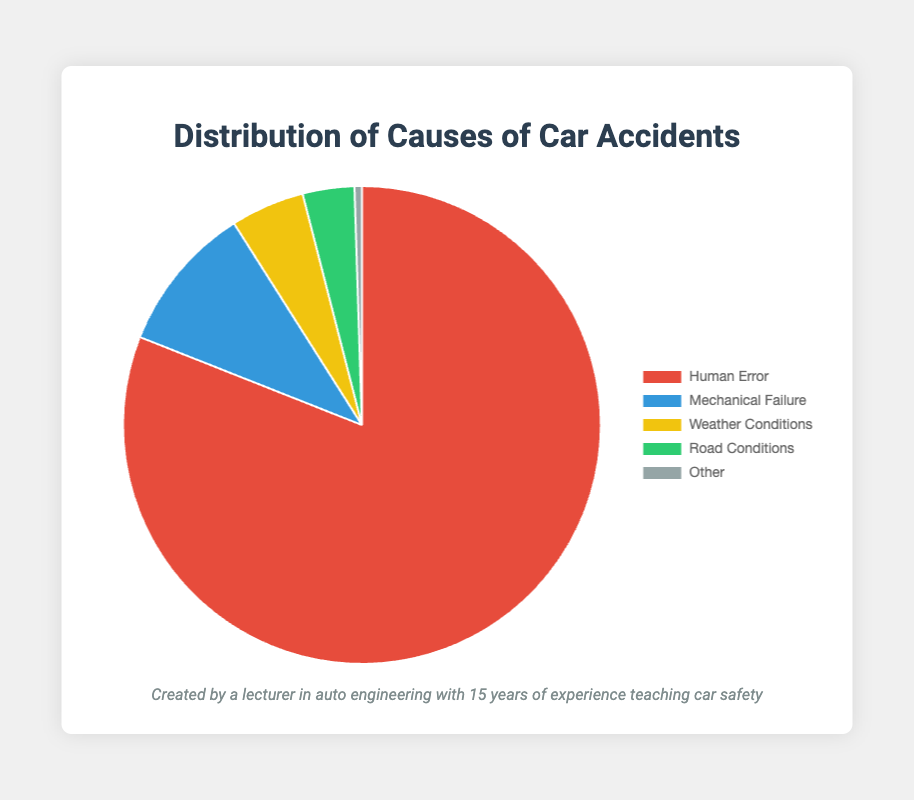Which cause has the highest percentage in the distribution? The chart shows different causes of car accidents along with their percentages. By inspecting the slices, we can see that "Human Error" has the largest slice.
Answer: Human Error Which two causes have the smallest percentages in the distribution? By looking at the sizes of the slices, we can identify that "Road Conditions" and "Other" have the smallest percentages, with "Other" being the smallest slice.
Answer: Road Conditions and Other What is the total percentage of accidents attributed to mechanical and weather-related causes? We need to add the percentages for "Mechanical Failure" and "Weather Conditions" from the figure: 10.0% + 5.0% = 15.0%.
Answer: 15.0% Is the percentage of accidents due to human error greater than the sum of all other causes? We compare the percentage of "Human Error" (81.0%) with the sum of the percentages of the other causes (10.0% + 5.0% + 3.5% + 0.5% = 19.0%). Since 81.0% is greater than 19.0%, the answer is yes.
Answer: Yes Which cause of car accidents is represented by a yellow slice in the pie chart? By looking at the legend associated with the pie chart, we can see that the yellow slice corresponds to "Weather Conditions".
Answer: Weather Conditions What is the percentage difference between accidents caused by human error and mechanical failure? Subtract the percentage of "Mechanical Failure" (10.0%) from "Human Error" (81.0%): 81.0% - 10.0% = 71.0%.
Answer: 71.0% Which causes have a difference of less than 2% between them? By comparing the percentages visually, we can see that "Road Conditions" (3.5%) and "Weather Conditions" (5.0%) have a difference of less than 2% because 5.0% - 3.5% = 1.5%.
Answer: Road Conditions and Weather Conditions What is the average percentage of all the given causes combined? Summing all the percentages: 81.0% + 10.0% + 5.0% + 3.5% + 0.5% = 100.0% and then dividing by the number of causes (5): 100.0% / 5 = 20.0%.
Answer: 20.0% Which color in the pie chart corresponds to the highest percentage of accidents? By looking at the legend and matching it with the visual attributes, the red slice corresponds to "Human Error", which has the highest percentage (81.0%).
Answer: Red 